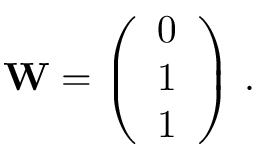Convert formula to latex. <formula><loc_0><loc_0><loc_500><loc_500>\begin{array} { r } { W = \left ( \begin{array} { l } { 0 } \\ { 1 } \\ { 1 } \end{array} \right ) \, . } \end{array}</formula> 